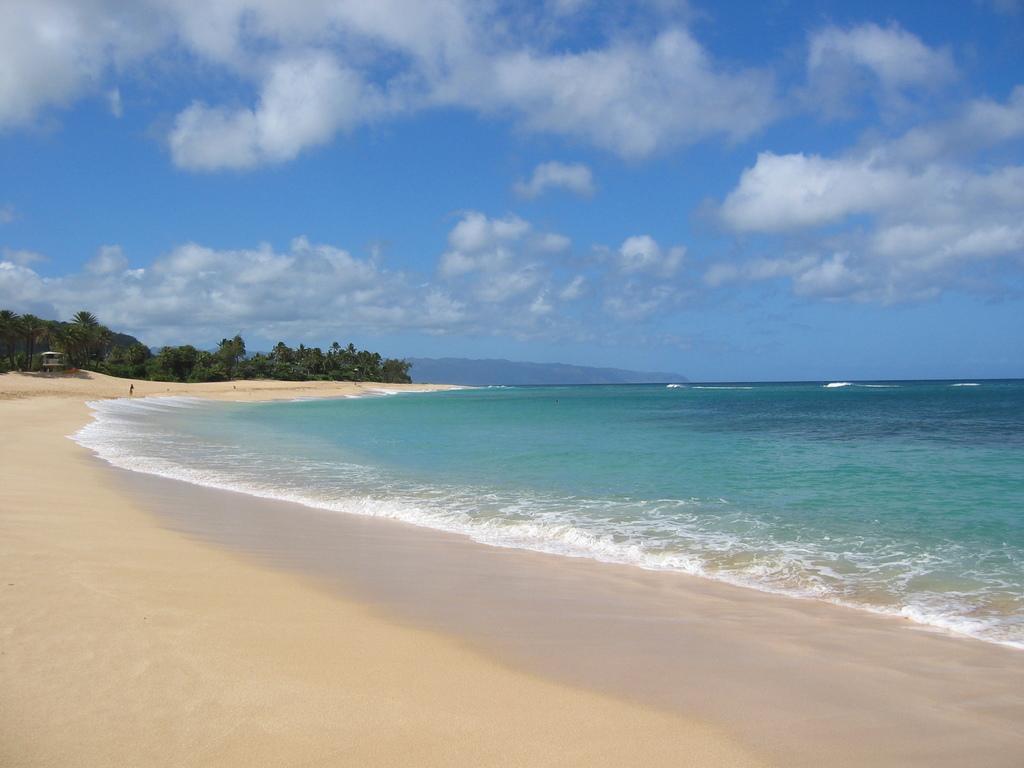Could you give a brief overview of what you see in this image? In this image we can see sea, sand, hut, trees, hills, sky and clouds. 